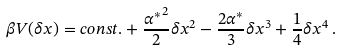<formula> <loc_0><loc_0><loc_500><loc_500>\beta V ( \delta x ) = c o n s t . + \frac { { \alpha ^ { \ast } } ^ { 2 } } { 2 } \delta x ^ { 2 } - \frac { 2 \alpha ^ { \ast } } { 3 } \delta x ^ { 3 } + \frac { 1 } { 4 } \delta x ^ { 4 } \, .</formula> 